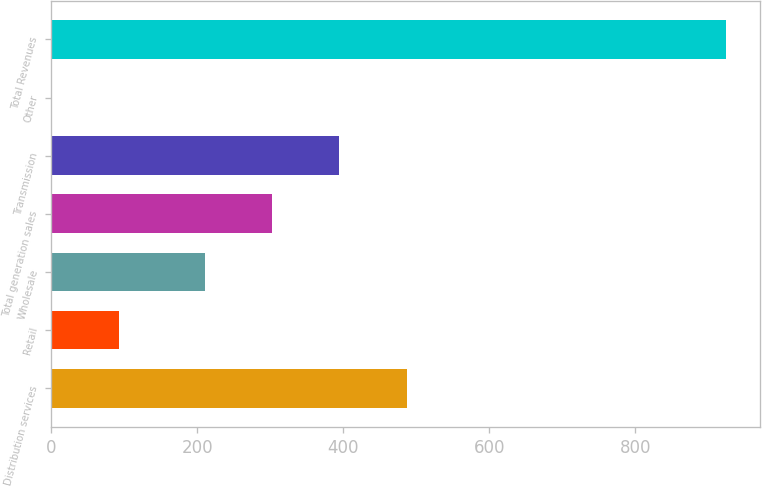Convert chart to OTSL. <chart><loc_0><loc_0><loc_500><loc_500><bar_chart><fcel>Distribution services<fcel>Retail<fcel>Wholesale<fcel>Total generation sales<fcel>Transmission<fcel>Other<fcel>Total Revenues<nl><fcel>486.9<fcel>93.3<fcel>210<fcel>302.3<fcel>394.6<fcel>1<fcel>924<nl></chart> 